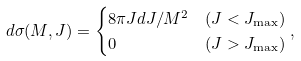Convert formula to latex. <formula><loc_0><loc_0><loc_500><loc_500>d \sigma ( M , J ) & = \begin{cases} 8 \pi J d J / M ^ { 2 } & ( J < J _ { \max } ) \\ 0 & ( J > J _ { \max } ) \end{cases} ,</formula> 